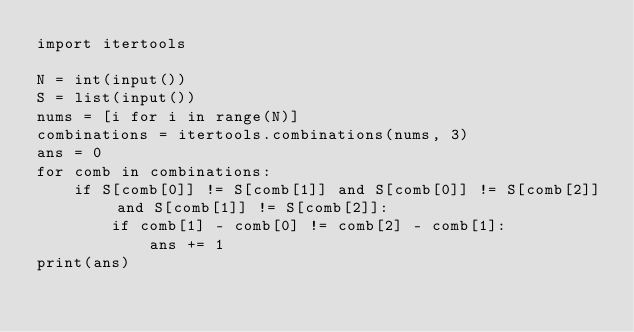Convert code to text. <code><loc_0><loc_0><loc_500><loc_500><_Python_>import itertools

N = int(input())
S = list(input())
nums = [i for i in range(N)]
combinations = itertools.combinations(nums, 3)
ans = 0
for comb in combinations:
    if S[comb[0]] != S[comb[1]] and S[comb[0]] != S[comb[2]] and S[comb[1]] != S[comb[2]]:
        if comb[1] - comb[0] != comb[2] - comb[1]:
            ans += 1
print(ans)</code> 